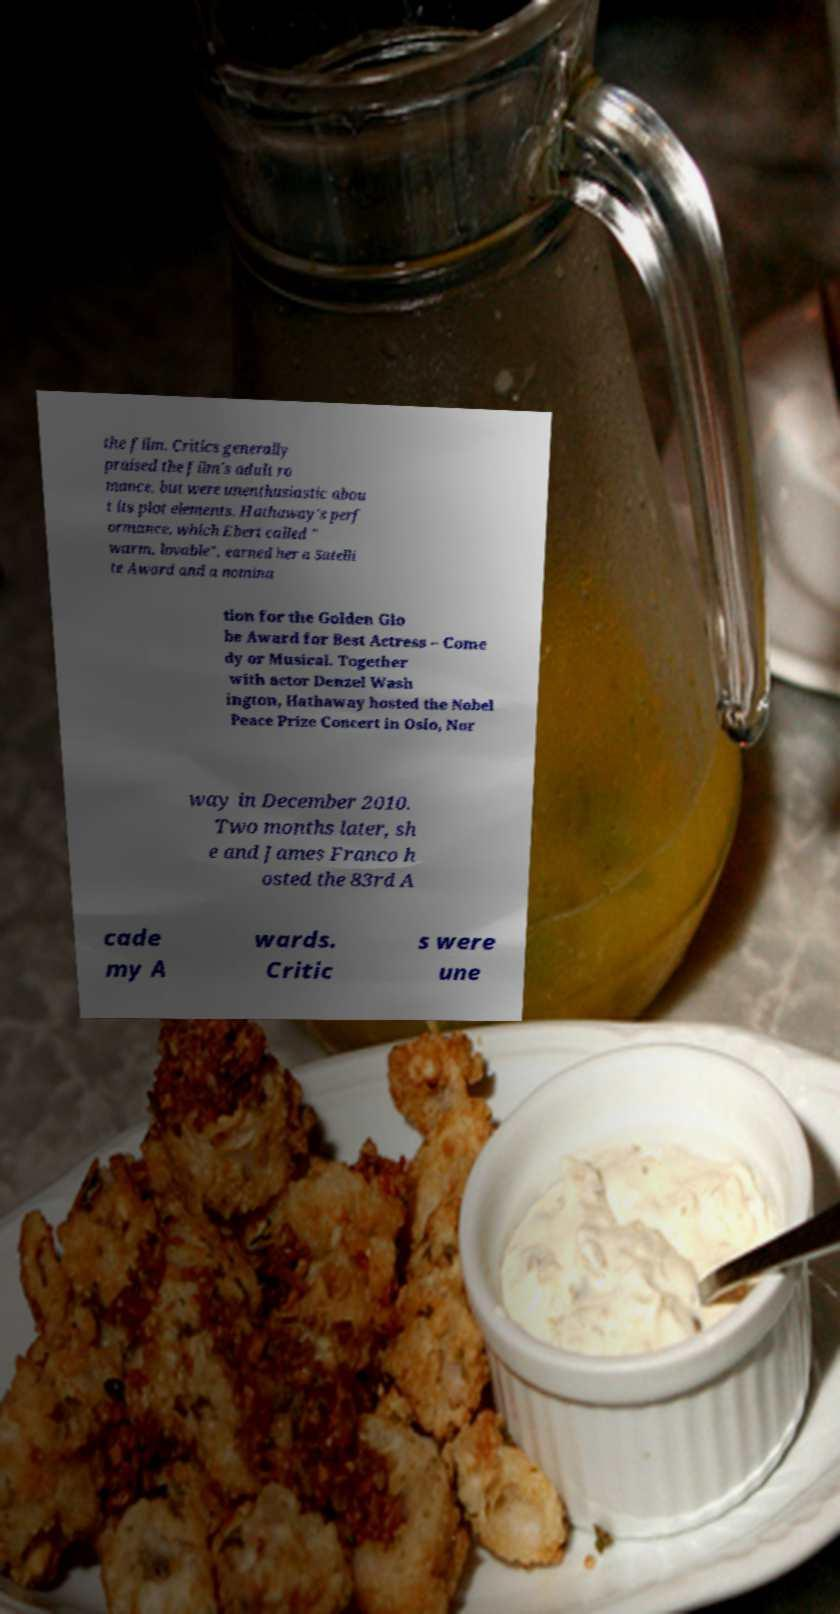What messages or text are displayed in this image? I need them in a readable, typed format. the film. Critics generally praised the film's adult ro mance, but were unenthusiastic abou t its plot elements. Hathaway's perf ormance, which Ebert called " warm, lovable", earned her a Satelli te Award and a nomina tion for the Golden Glo be Award for Best Actress – Come dy or Musical. Together with actor Denzel Wash ington, Hathaway hosted the Nobel Peace Prize Concert in Oslo, Nor way in December 2010. Two months later, sh e and James Franco h osted the 83rd A cade my A wards. Critic s were une 